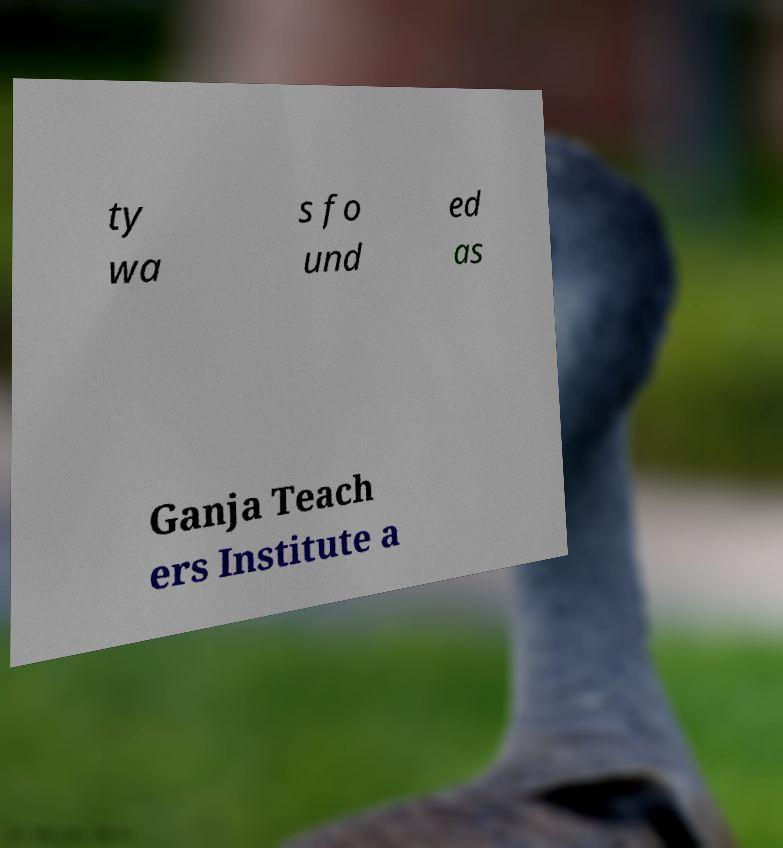Please identify and transcribe the text found in this image. ty wa s fo und ed as Ganja Teach ers Institute a 